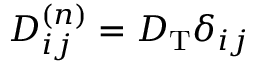Convert formula to latex. <formula><loc_0><loc_0><loc_500><loc_500>D _ { i j } ^ { ( n ) } = D _ { T } \delta _ { i j }</formula> 